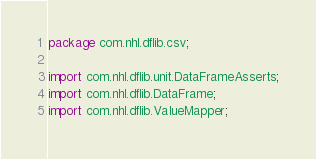<code> <loc_0><loc_0><loc_500><loc_500><_Java_>package com.nhl.dflib.csv;

import com.nhl.dflib.unit.DataFrameAsserts;
import com.nhl.dflib.DataFrame;
import com.nhl.dflib.ValueMapper;</code> 